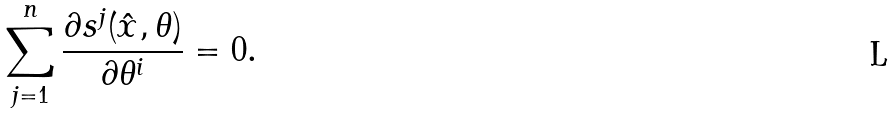<formula> <loc_0><loc_0><loc_500><loc_500>\sum _ { j = 1 } ^ { n } \frac { \partial { s ^ { j } ( \hat { x } , \theta ) } } { \partial { \theta ^ { i } } } = 0 .</formula> 